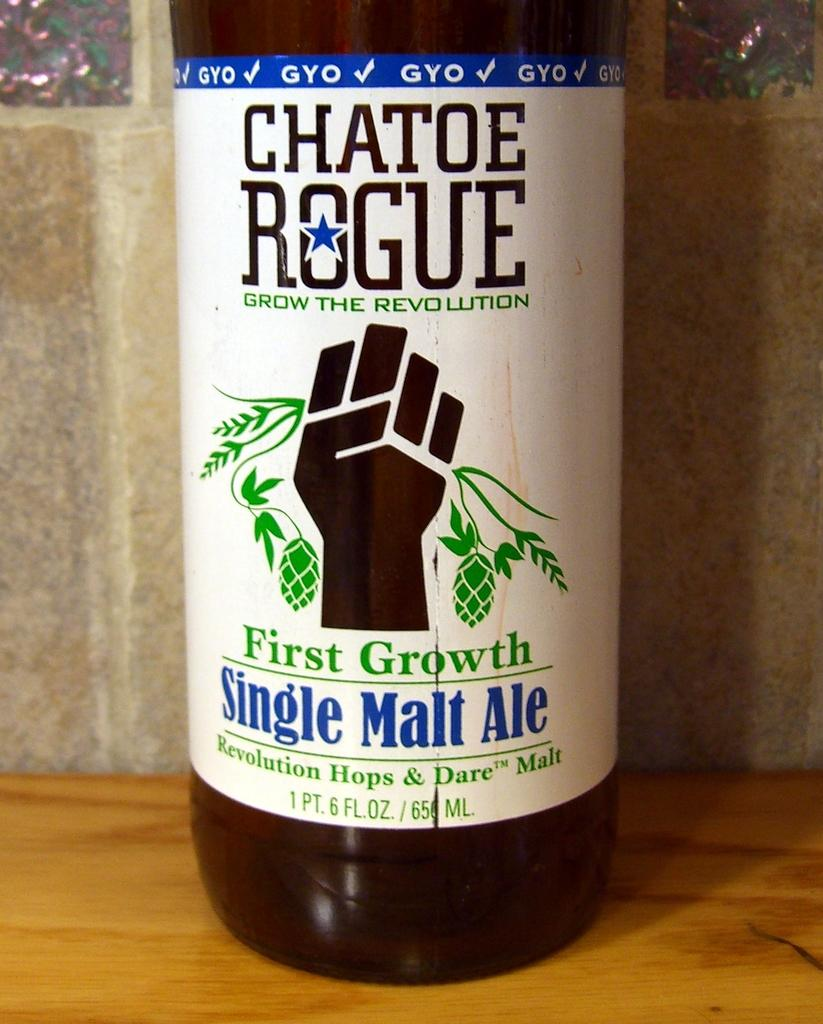<image>
Write a terse but informative summary of the picture. A bottle of Chatoe Rogue has a image of a hand holding plants on its label. 